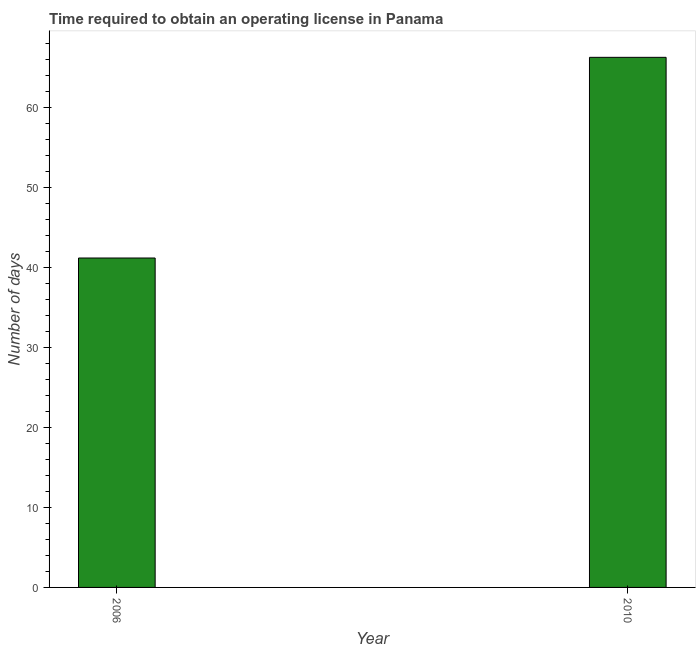Does the graph contain grids?
Make the answer very short. No. What is the title of the graph?
Keep it short and to the point. Time required to obtain an operating license in Panama. What is the label or title of the X-axis?
Provide a succinct answer. Year. What is the label or title of the Y-axis?
Offer a terse response. Number of days. What is the number of days to obtain operating license in 2006?
Your answer should be very brief. 41.2. Across all years, what is the maximum number of days to obtain operating license?
Keep it short and to the point. 66.3. Across all years, what is the minimum number of days to obtain operating license?
Your answer should be compact. 41.2. In which year was the number of days to obtain operating license maximum?
Provide a succinct answer. 2010. What is the sum of the number of days to obtain operating license?
Provide a short and direct response. 107.5. What is the difference between the number of days to obtain operating license in 2006 and 2010?
Make the answer very short. -25.1. What is the average number of days to obtain operating license per year?
Make the answer very short. 53.75. What is the median number of days to obtain operating license?
Your answer should be compact. 53.75. In how many years, is the number of days to obtain operating license greater than 6 days?
Give a very brief answer. 2. What is the ratio of the number of days to obtain operating license in 2006 to that in 2010?
Offer a very short reply. 0.62. In how many years, is the number of days to obtain operating license greater than the average number of days to obtain operating license taken over all years?
Ensure brevity in your answer.  1. How many bars are there?
Keep it short and to the point. 2. How many years are there in the graph?
Keep it short and to the point. 2. What is the Number of days in 2006?
Offer a very short reply. 41.2. What is the Number of days in 2010?
Offer a very short reply. 66.3. What is the difference between the Number of days in 2006 and 2010?
Provide a succinct answer. -25.1. What is the ratio of the Number of days in 2006 to that in 2010?
Give a very brief answer. 0.62. 